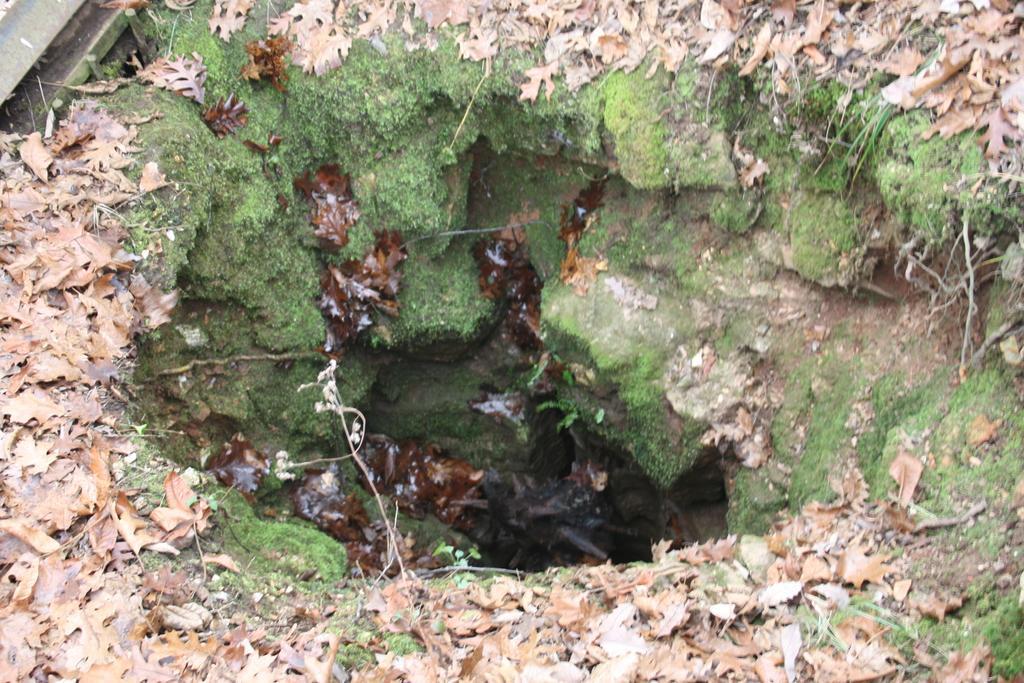How would you summarize this image in a sentence or two? In this picture we can see some leaves, there is a pit in the middle. 